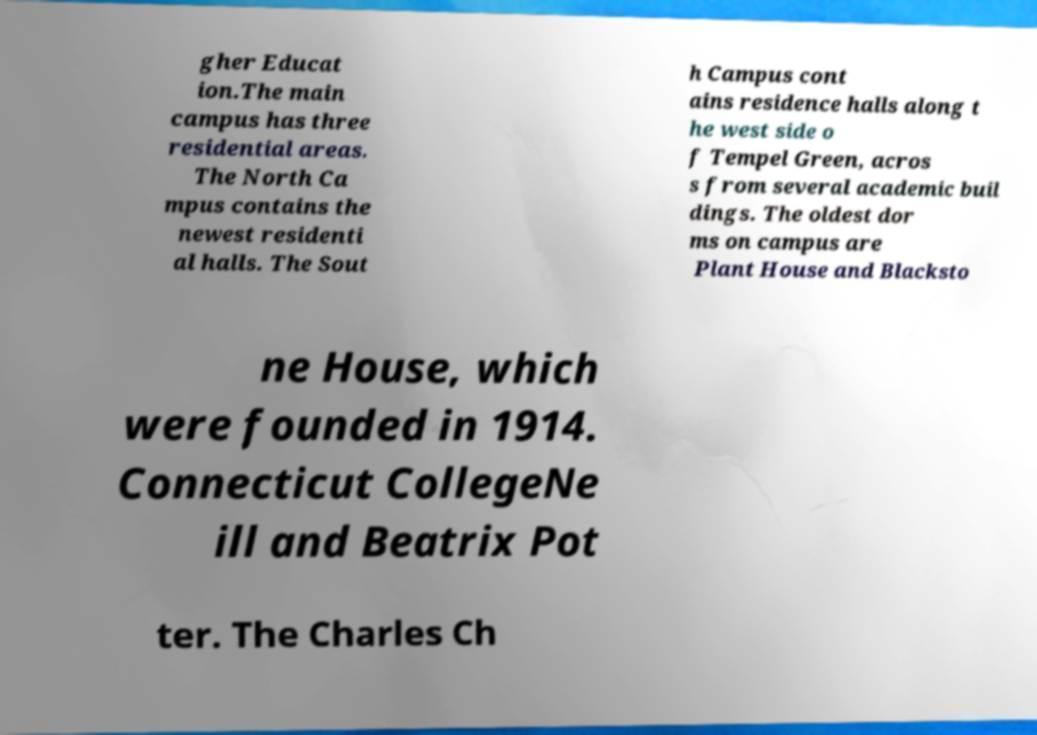I need the written content from this picture converted into text. Can you do that? gher Educat ion.The main campus has three residential areas. The North Ca mpus contains the newest residenti al halls. The Sout h Campus cont ains residence halls along t he west side o f Tempel Green, acros s from several academic buil dings. The oldest dor ms on campus are Plant House and Blacksto ne House, which were founded in 1914. Connecticut CollegeNe ill and Beatrix Pot ter. The Charles Ch 